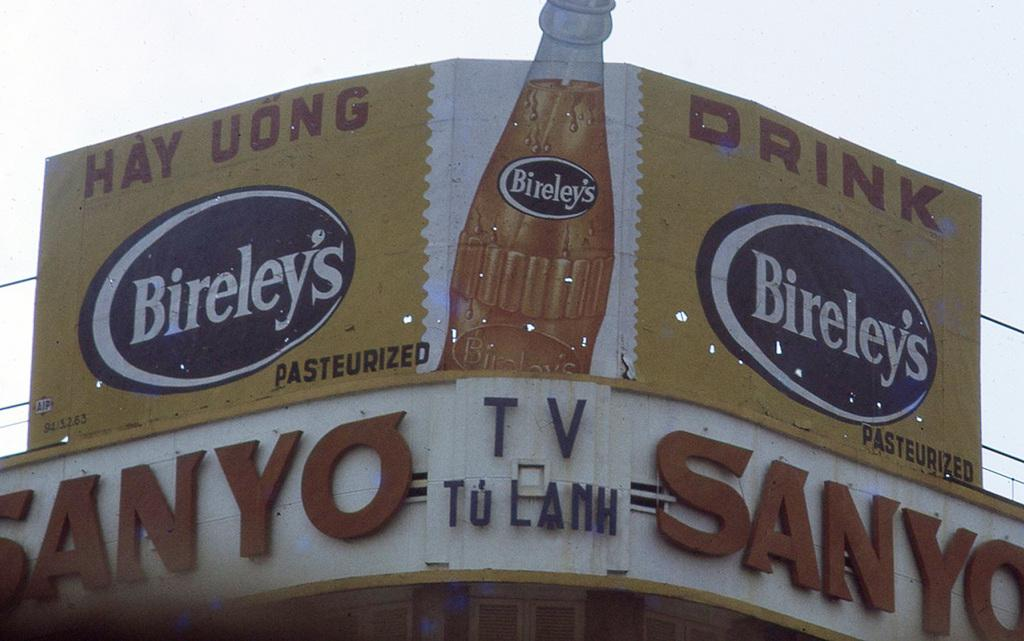<image>
Summarize the visual content of the image. A large yellow billboard advertising Bireley's pasteurized drink 